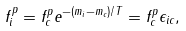Convert formula to latex. <formula><loc_0><loc_0><loc_500><loc_500>f _ { i } ^ { p } = f _ { c } ^ { p } e ^ { - ( m _ { i } - m _ { c } ) / T } = f _ { c } ^ { p } \epsilon _ { i c } ,</formula> 